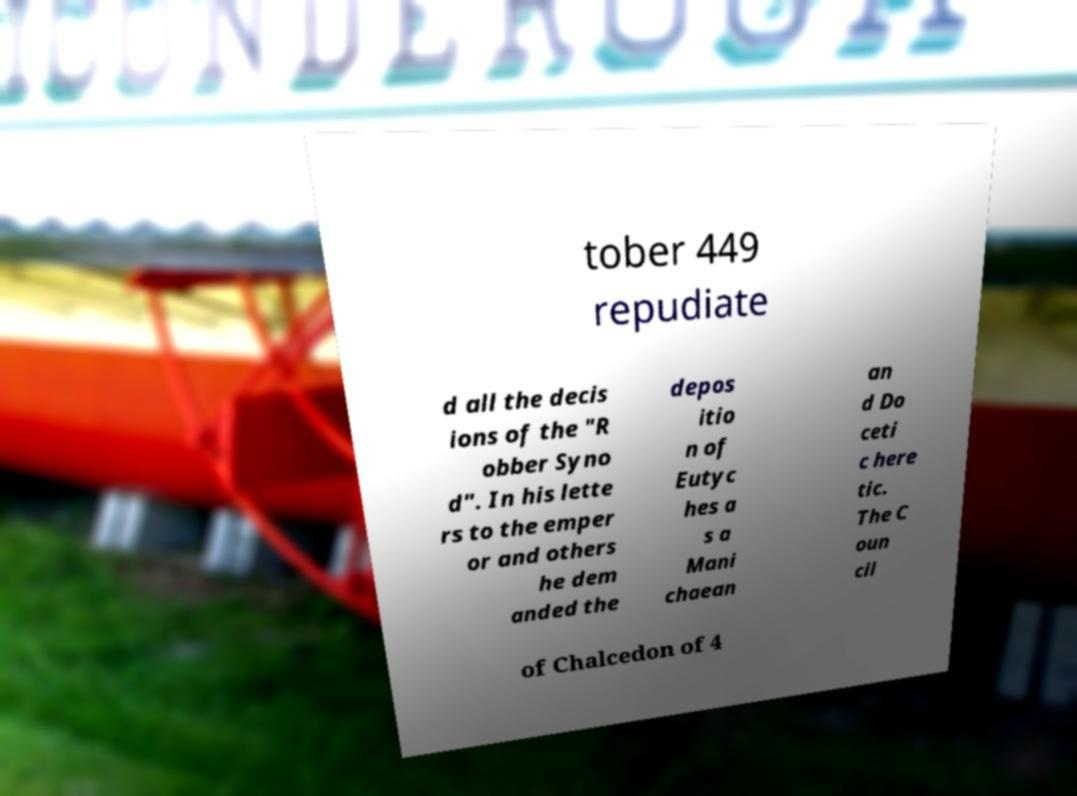Please identify and transcribe the text found in this image. tober 449 repudiate d all the decis ions of the "R obber Syno d". In his lette rs to the emper or and others he dem anded the depos itio n of Eutyc hes a s a Mani chaean an d Do ceti c here tic. The C oun cil of Chalcedon of 4 